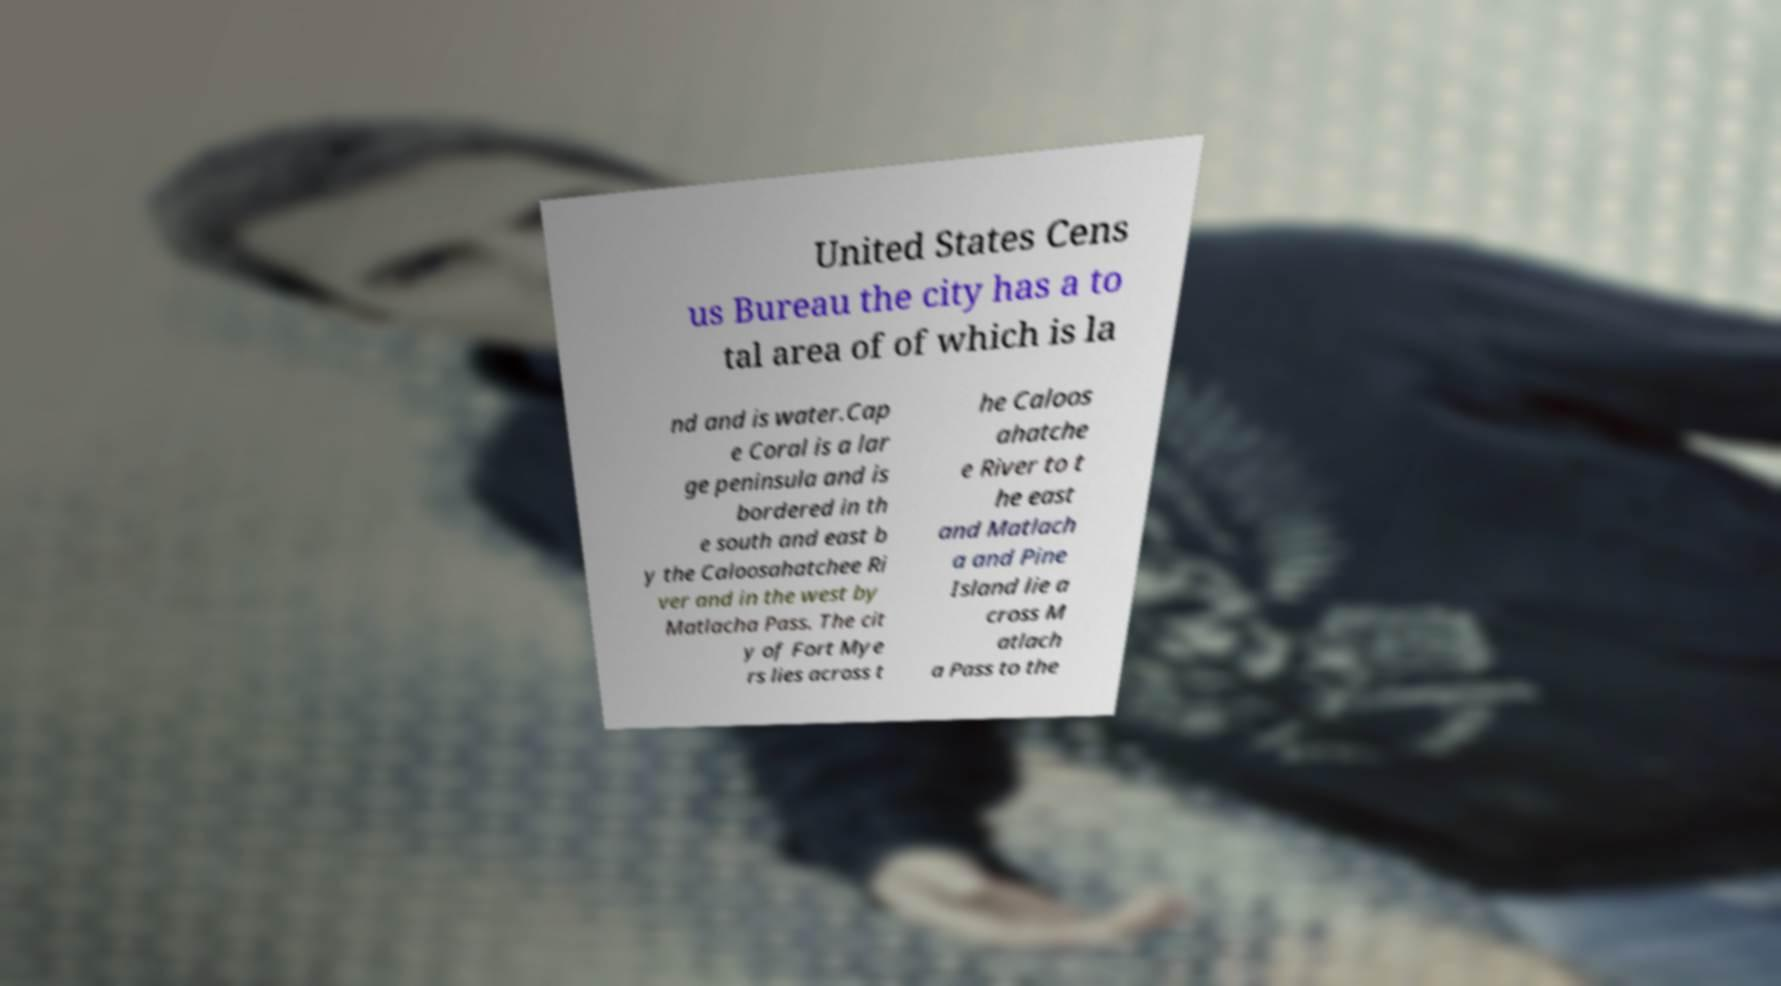Please identify and transcribe the text found in this image. United States Cens us Bureau the city has a to tal area of of which is la nd and is water.Cap e Coral is a lar ge peninsula and is bordered in th e south and east b y the Caloosahatchee Ri ver and in the west by Matlacha Pass. The cit y of Fort Mye rs lies across t he Caloos ahatche e River to t he east and Matlach a and Pine Island lie a cross M atlach a Pass to the 